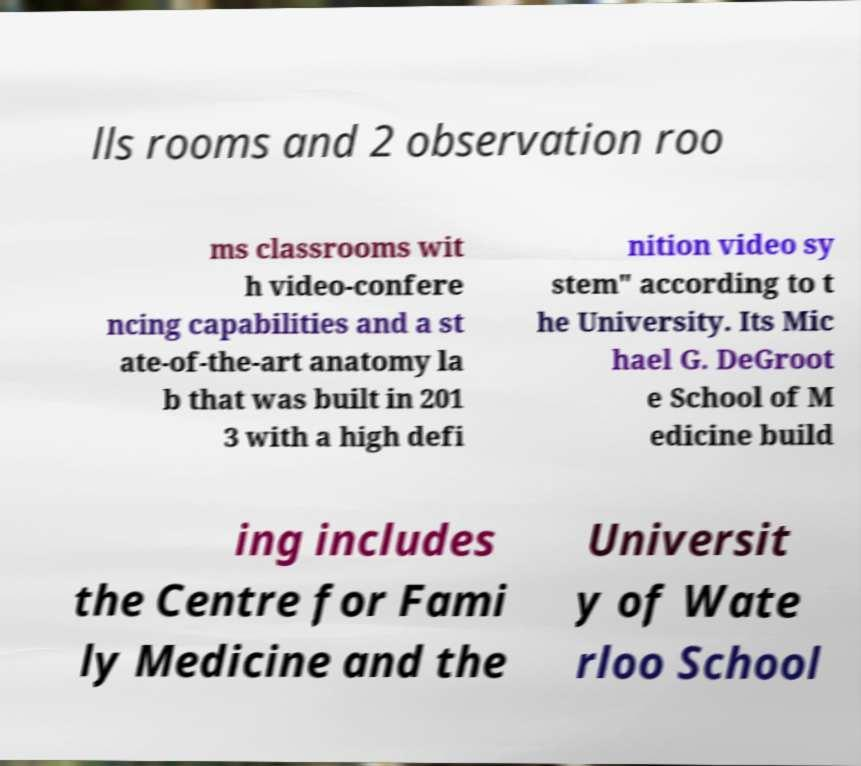Can you accurately transcribe the text from the provided image for me? lls rooms and 2 observation roo ms classrooms wit h video-confere ncing capabilities and a st ate-of-the-art anatomy la b that was built in 201 3 with a high defi nition video sy stem" according to t he University. Its Mic hael G. DeGroot e School of M edicine build ing includes the Centre for Fami ly Medicine and the Universit y of Wate rloo School 